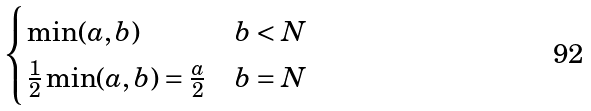Convert formula to latex. <formula><loc_0><loc_0><loc_500><loc_500>\begin{cases} \min ( a , b ) & b < N \\ \frac { 1 } { 2 } \min ( a , b ) = \frac { a } { 2 } & b = N \end{cases}</formula> 